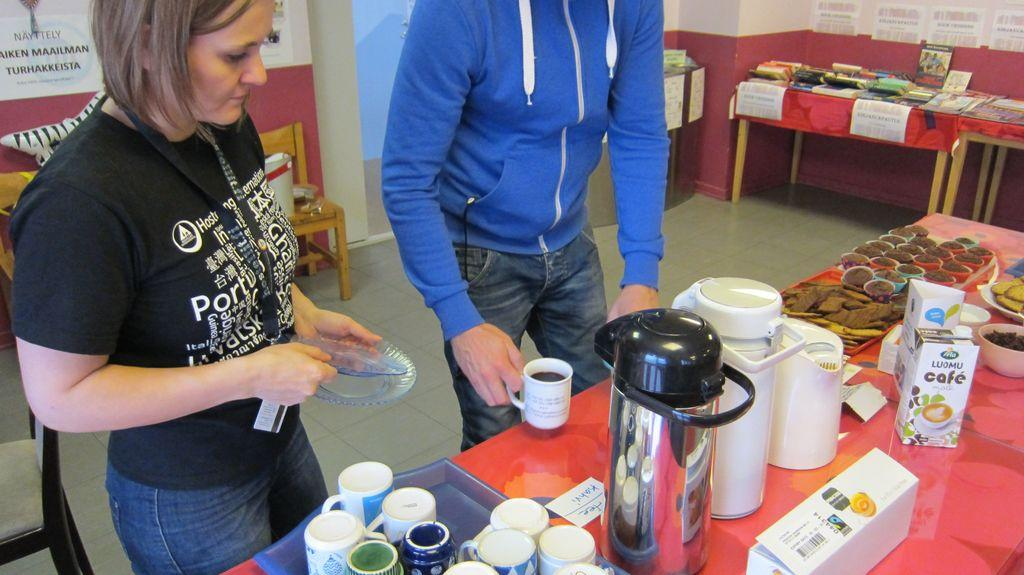Provide a one-sentence caption for the provided image. A man in a blue hoodie serves up a beverage in front of a bottle of Luomu Café creamer. 